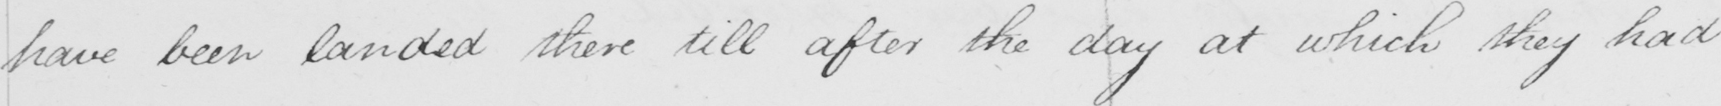What is written in this line of handwriting? have been landed there till after the day at which they had 